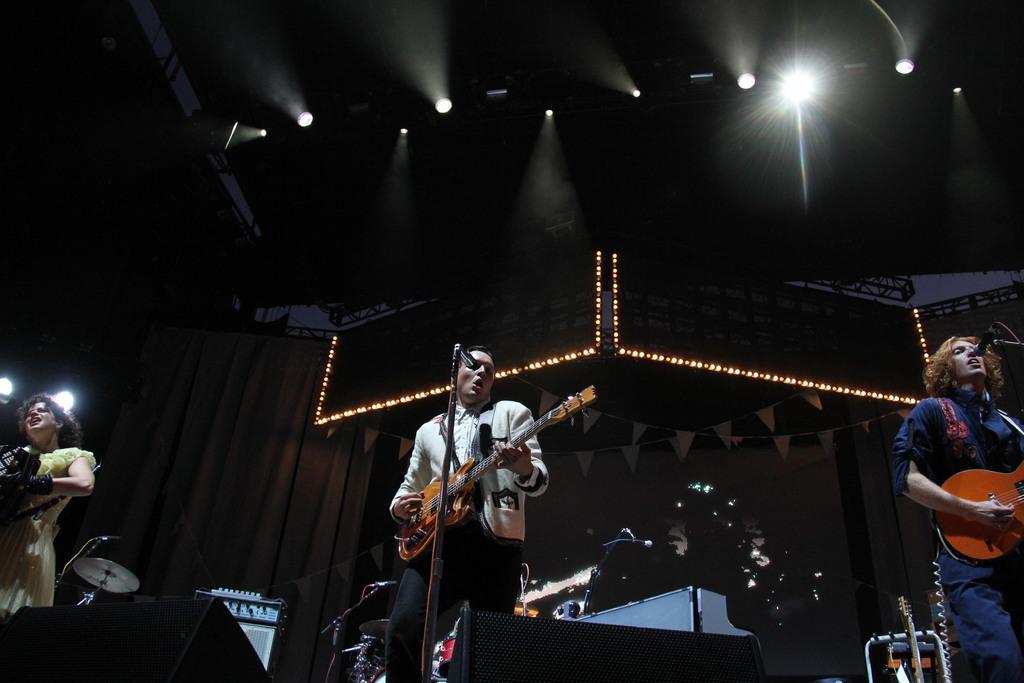Could you give a brief overview of what you see in this image? In the middle of the image a man is holding a guitar and singing. Bottom right side of the image a man is holding a guitar and singing. Bottom left side of the image a woman holding something in her hands. At the top of the image there is a roof and lights. In the middle of the image there is a screen. 